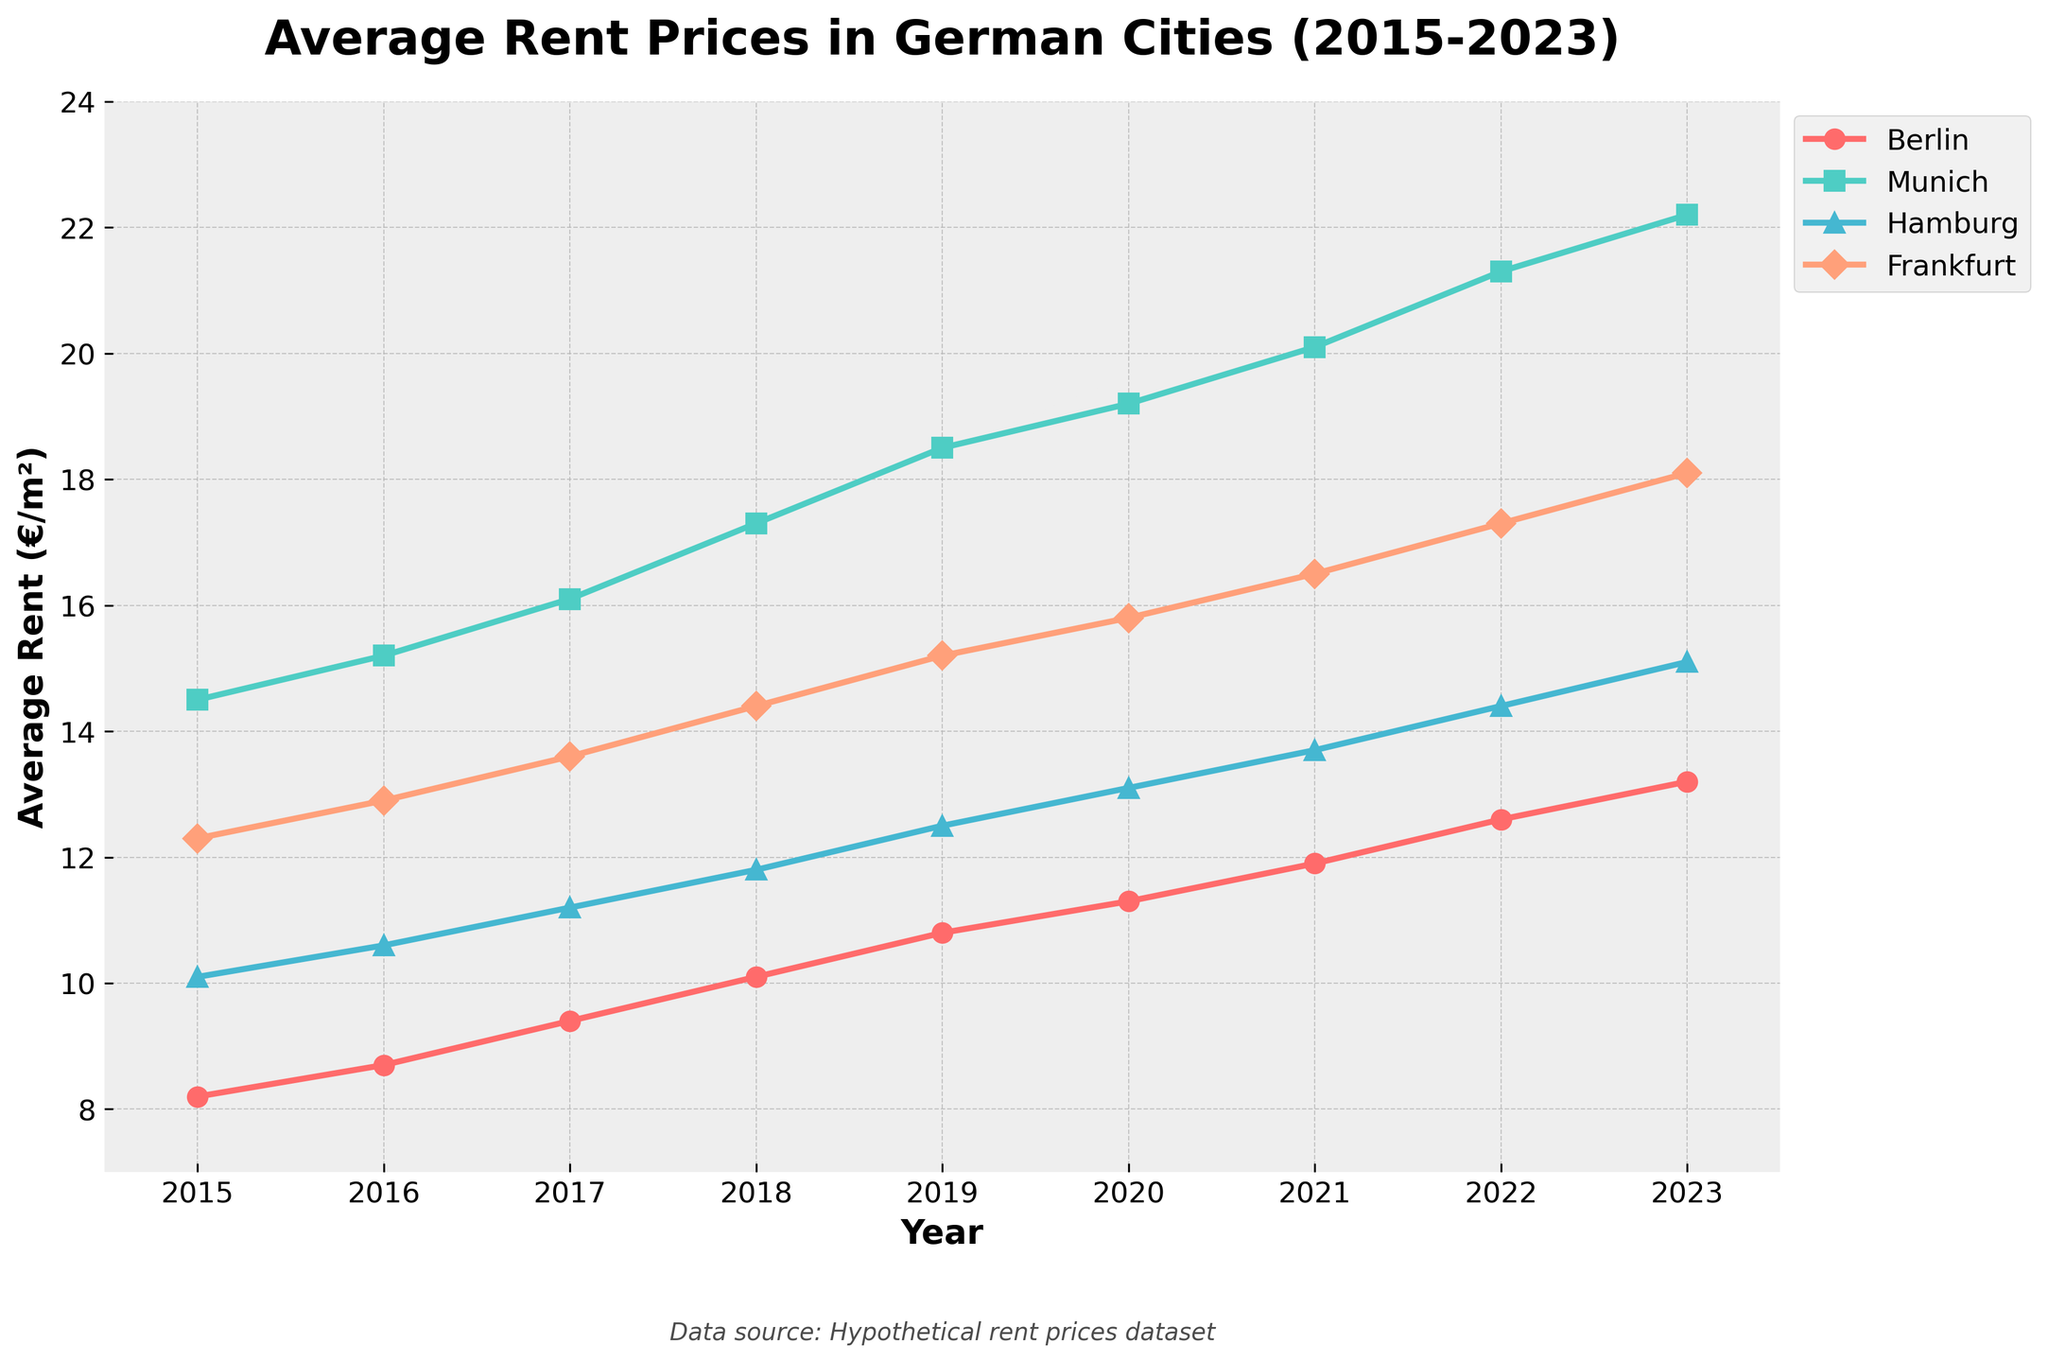What is the trend in average rent prices in Berlin from 2015 to 2023? The average rent prices in Berlin have been steadily increasing each year from 8.2 €/m² in 2015 to 13.2 €/m² in 2023.
Answer: Steadily increasing Which city had the highest average rent in 2023? In 2023, Munich had the highest average rent compared to Berlin, Hamburg, and Frankfurt, with an average rent of 22.2 €/m².
Answer: Munich What is the difference in average rent prices between Frankfurt and Hamburg in 2022? The average rent in Frankfurt in 2022 was 17.3 €/m² and in Hamburg, it was 14.4 €/m². The difference is 17.3 - 14.4 = 2.9 €/m².
Answer: 2.9 €/m² Did the rent prices in any of the cities decrease at any point from 2015 to 2023? By inspecting the trend lines for each city, we see that the rent prices in all cities have steadily increased over the years without any decrease.
Answer: No Which city had the fastest-growing rent prices over the period 2015-2023, and what was the growth rate? By comparing the slopes of the lines, Munich had the fastest-growing rent prices from 14.5 €/m² in 2015 to 22.2 €/m² in 2023. The growth rate is (22.2 - 14.5) / 14.5 ≈ 0.531, or 53.1%.
Answer: Munich, 53.1% In which year did Berlin surpass an average rent price of 10 €/m²? By looking at Berlin’s trend line, Berlin’s average rent price surpassed 10 €/m² in the year 2018.
Answer: 2018 What is the total increase in rent prices in Hamburg from 2015 to 2023? The average rent in Hamburg increased from 10.1 €/m² in 2015 to 15.1 €/m² in 2023. The total increase is 15.1 - 10.1 = 5.0 €/m².
Answer: 5.0 €/m² Rank the cities by their average rent in 2020 from highest to lowest. In 2020, the average rents are: Munich (19.2 €/m²), Frankfurt (15.8 €/m²), Hamburg (13.1 €/m²), Berlin (11.3 €/m²). The ranking from highest to lowest is Munich, Frankfurt, Hamburg, Berlin.
Answer: Munich, Frankfurt, Hamburg, Berlin What is the visual difference between the trend lines of Berlin and Munich? The trend line for Berlin has a shallower slope and a lower vertical position compared to Munich’s trend line, which has a steeper slope and a higher vertical position, indicating faster rental growth and higher prices in Munich.
Answer: Steeper slope and higher prices in Munich 